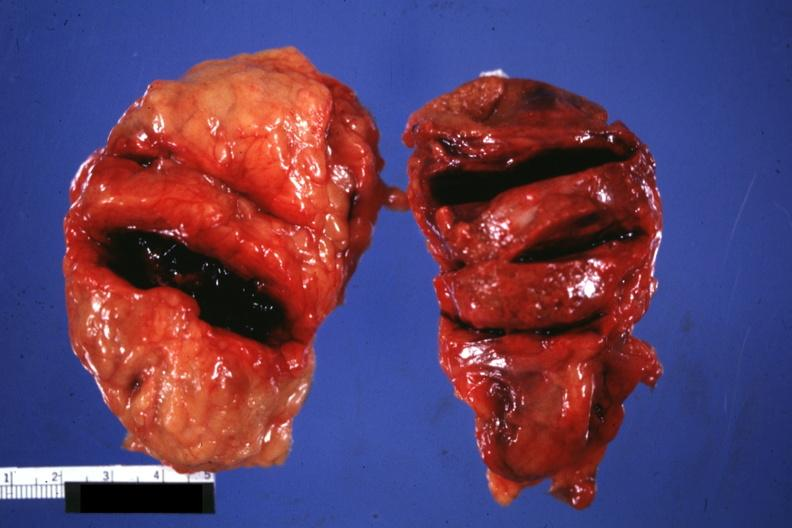s external view of gland with knife cuts into parenchyma hemorrhage obvious?
Answer the question using a single word or phrase. Yes 